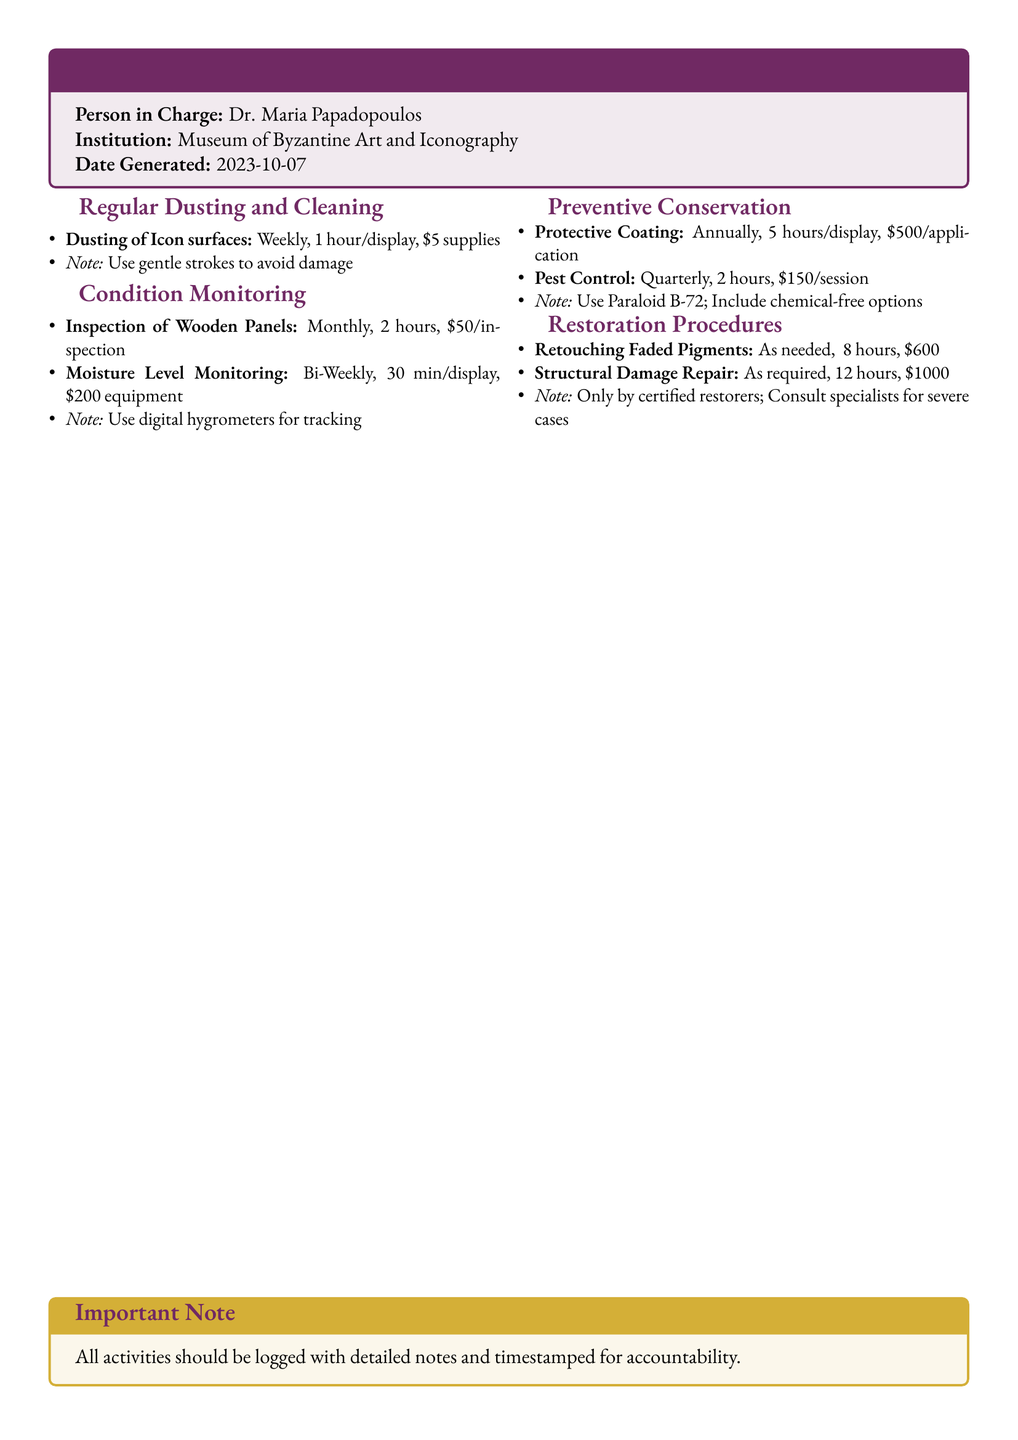What is the name of the person in charge? The document specifies the name of the person in charge as Dr. Maria Papadopoulos.
Answer: Dr. Maria Papadopoulos What is the inspection frequency for wooden panels? The document states that inspections for wooden panels are conducted monthly.
Answer: Monthly How long is the protective coating application per display? According to the document, the protective coating application takes 5 hours per display.
Answer: 5 hours What is the cost of retouching faded pigments? The document indicates that the cost of retouching faded pigments is $600.
Answer: $600 How often is pest control performed? The document details that pest control is performed quarterly.
Answer: Quarterly What equipment is used for moisture level monitoring? The document specifies that digital hygrometers are used for monitoring moisture levels.
Answer: Digital hygrometers What is the duration of structural damage repair? The document mentions that structural damage repair takes 12 hours.
Answer: 12 hours What note is provided for the application of protective coating? The document states to use Paraloid B-72 and include chemical-free options.
Answer: Use Paraloid B-72; Include chemical-free options How often is dusting of icon surfaces done? The document mentions that dusting of icon surfaces is done weekly.
Answer: Weekly 